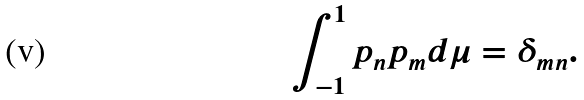Convert formula to latex. <formula><loc_0><loc_0><loc_500><loc_500>\int _ { - 1 } ^ { 1 } p _ { n } p _ { m } d \mu = \delta _ { m n } .</formula> 